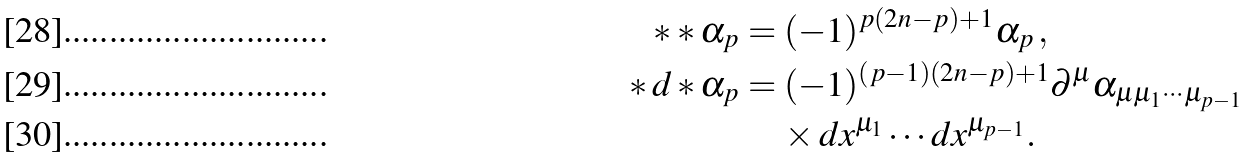<formula> <loc_0><loc_0><loc_500><loc_500>\ast \ast \alpha _ { p } & = ( - 1 ) ^ { p ( 2 n - p ) + 1 } \alpha _ { p } \, , \\ \ast \, d \ast \alpha _ { p } & = ( - 1 ) ^ { ( p - 1 ) ( 2 n - p ) + 1 } \partial ^ { \mu } \alpha _ { \mu \mu _ { 1 } \cdots \mu _ { p - 1 } } \\ & \quad \, \times d x ^ { \mu _ { 1 } } \cdots d x ^ { \mu _ { p - 1 } } .</formula> 